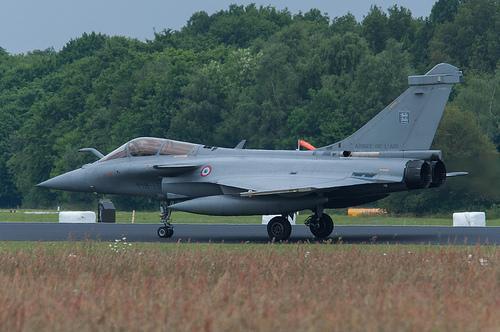How many planes are there?
Give a very brief answer. 1. How many wheels are on the ground?
Give a very brief answer. 3. 